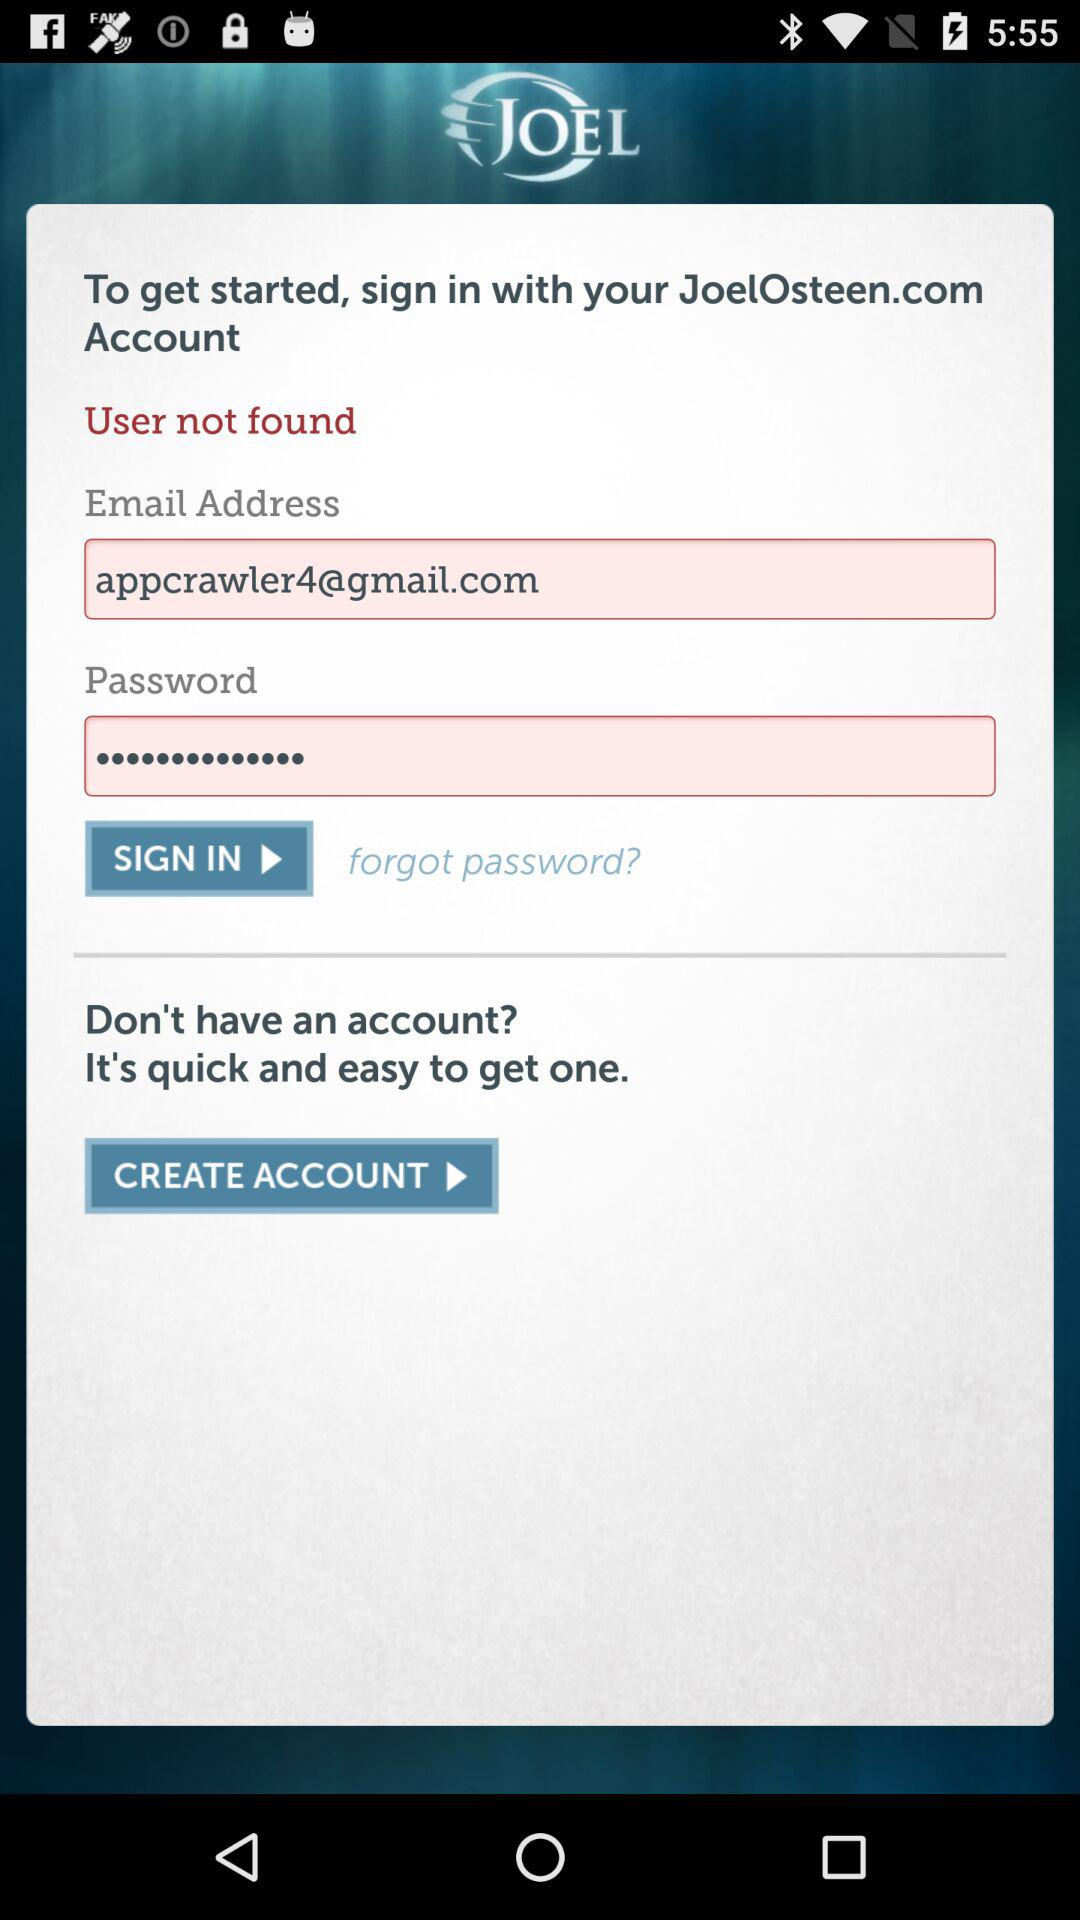What is the email address? The email address is appcrawler4@gmail.com. 